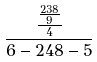Convert formula to latex. <formula><loc_0><loc_0><loc_500><loc_500>\frac { \frac { \frac { 2 3 8 } { 9 } } { 4 } } { 6 - 2 4 8 - 5 }</formula> 